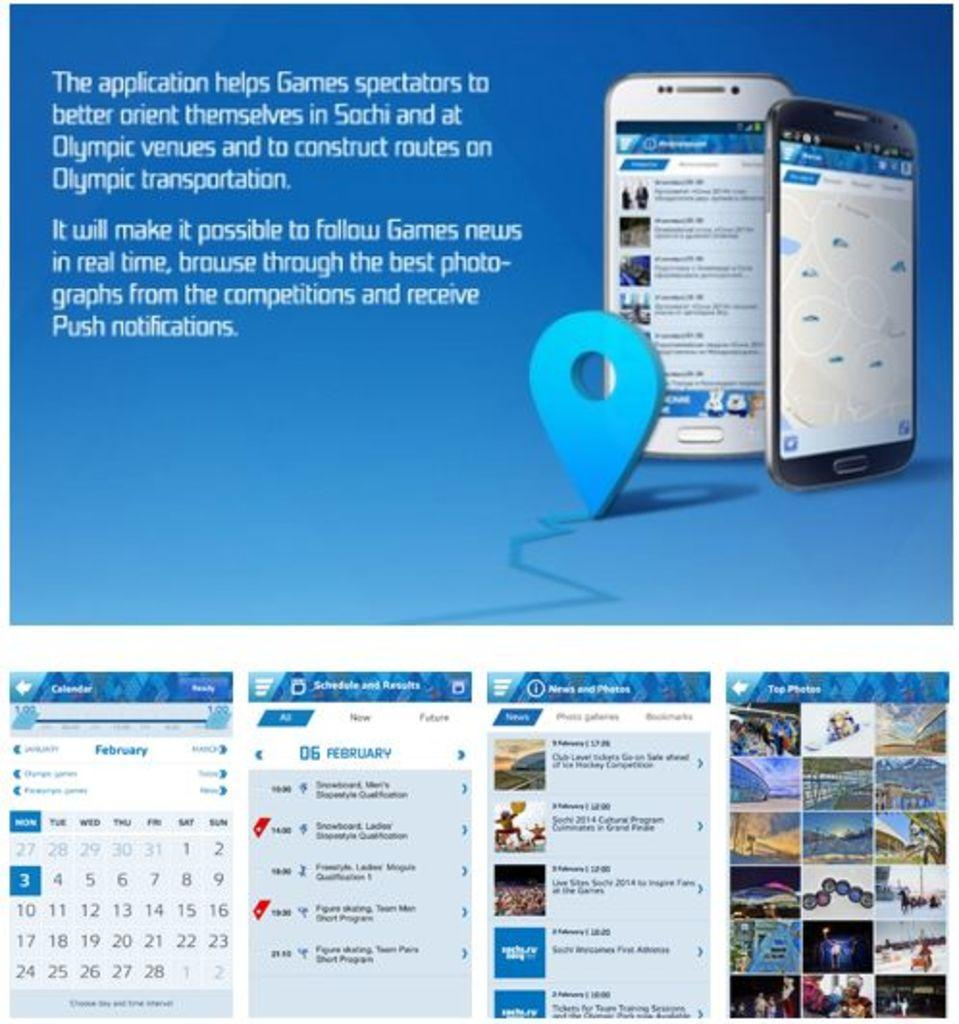<image>
Offer a succinct explanation of the picture presented. An app designed for keeping up with the Sochi Olympics. 